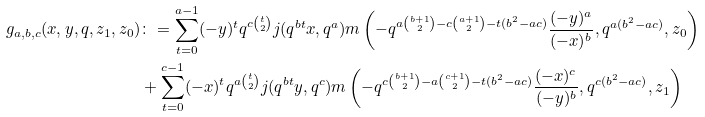Convert formula to latex. <formula><loc_0><loc_0><loc_500><loc_500>g _ { a , b , c } ( x , y , q , z _ { 1 } , z _ { 0 } ) & \colon = \sum _ { t = 0 } ^ { a - 1 } ( - y ) ^ { t } q ^ { c \binom { t } { 2 } } j ( q ^ { b t } x , q ^ { a } ) m \left ( - q ^ { a \binom { b + 1 } { 2 } - c \binom { a + 1 } { 2 } - t ( b ^ { 2 } - a c ) } \frac { ( - y ) ^ { a } } { ( - x ) ^ { b } } , q ^ { a ( b ^ { 2 } - a c ) } , z _ { 0 } \right ) \\ & + \sum _ { t = 0 } ^ { c - 1 } ( - x ) ^ { t } q ^ { a \binom { t } { 2 } } j ( q ^ { b t } y , q ^ { c } ) m \left ( - q ^ { c \binom { b + 1 } { 2 } - a \binom { c + 1 } { 2 } - t ( b ^ { 2 } - a c ) } \frac { ( - x ) ^ { c } } { ( - y ) ^ { b } } , q ^ { c ( b ^ { 2 } - a c ) } , z _ { 1 } \right )</formula> 